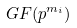Convert formula to latex. <formula><loc_0><loc_0><loc_500><loc_500>G F ( p ^ { m _ { i } } )</formula> 